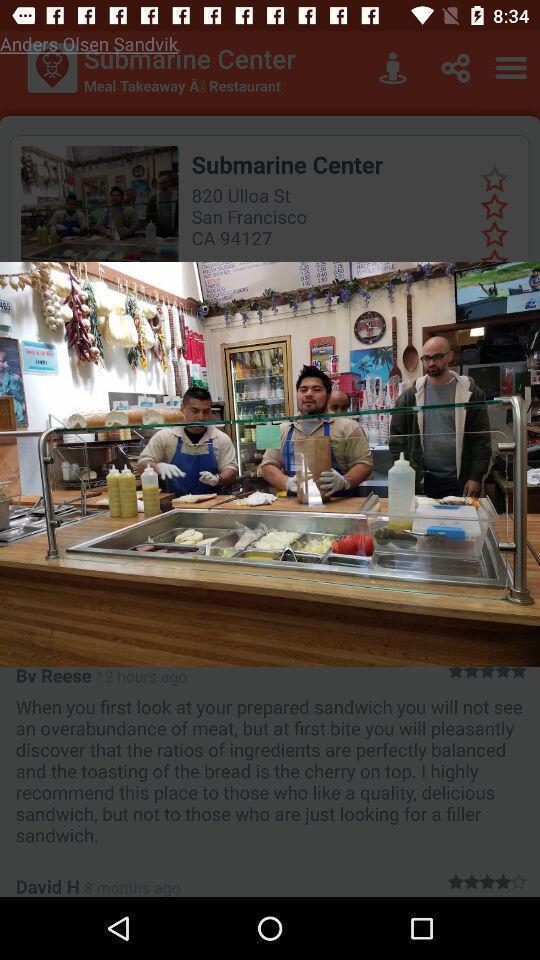Provide a detailed account of this screenshot. Pop up page displaying an image. 